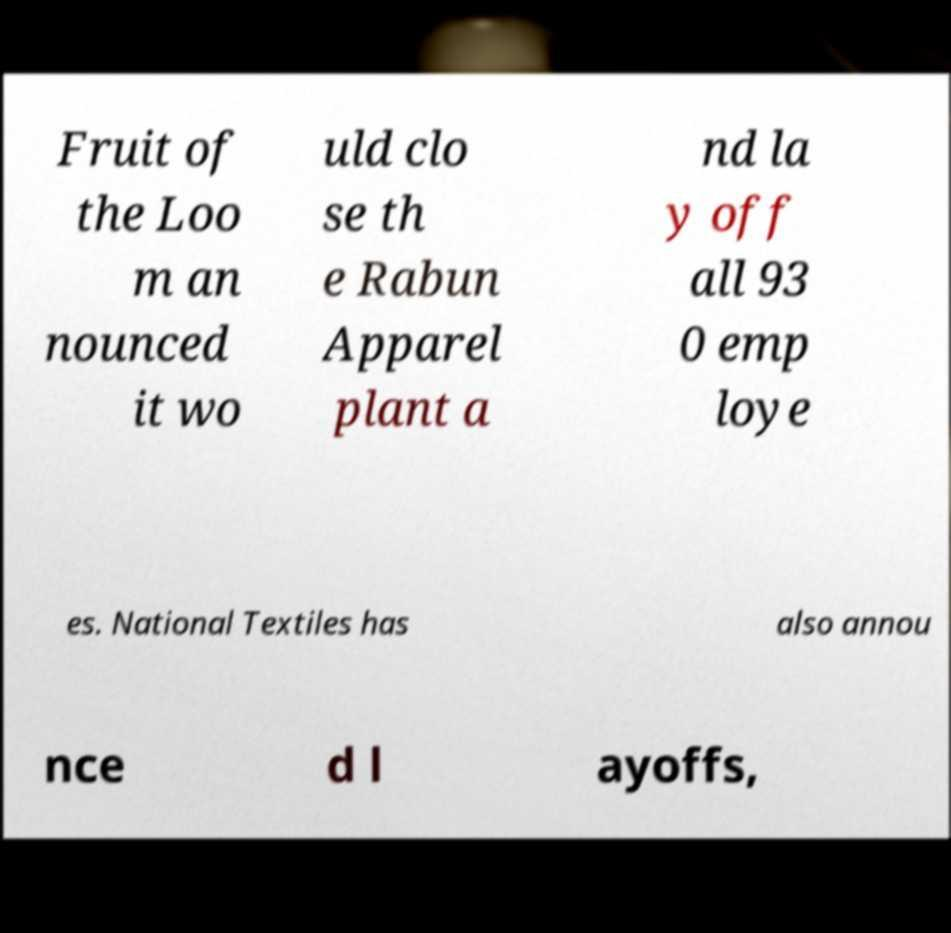I need the written content from this picture converted into text. Can you do that? Fruit of the Loo m an nounced it wo uld clo se th e Rabun Apparel plant a nd la y off all 93 0 emp loye es. National Textiles has also annou nce d l ayoffs, 